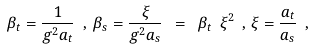Convert formula to latex. <formula><loc_0><loc_0><loc_500><loc_500>\beta _ { t } = \frac { 1 } { g ^ { 2 } a _ { t } } \ , \, \beta _ { s } = \frac { \xi } { g ^ { 2 } a _ { s } } \ = \ \beta _ { t } \ \xi ^ { 2 } \ , \, \xi = \frac { a _ { t } } { a _ { s } } \ ,</formula> 